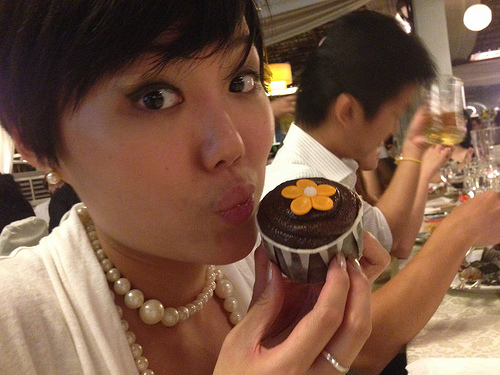Is there any indication of specific celebration or event going on? While the image does not explicitly indicate a specific celebration, the presence of a decorated dessert, the joyful expression of the woman holding it, and the overall lively atmosphere suggest a celebratory event, possibly a birthday or a friendly gathering. 